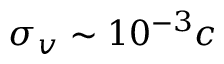<formula> <loc_0><loc_0><loc_500><loc_500>\sigma _ { v } \sim 1 0 ^ { - 3 } c</formula> 